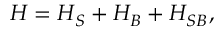Convert formula to latex. <formula><loc_0><loc_0><loc_500><loc_500>H = H _ { S } + H _ { B } + H _ { S B } ,</formula> 